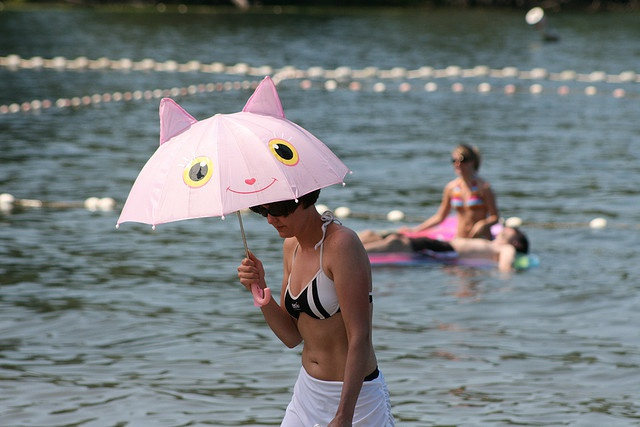Describe the objects in this image and their specific colors. I can see people in black, maroon, and brown tones, umbrella in black, lavender, pink, lightpink, and darkgray tones, people in black, tan, and gray tones, people in black, maroon, brown, salmon, and gray tones, and surfboard in black, violet, gray, and purple tones in this image. 